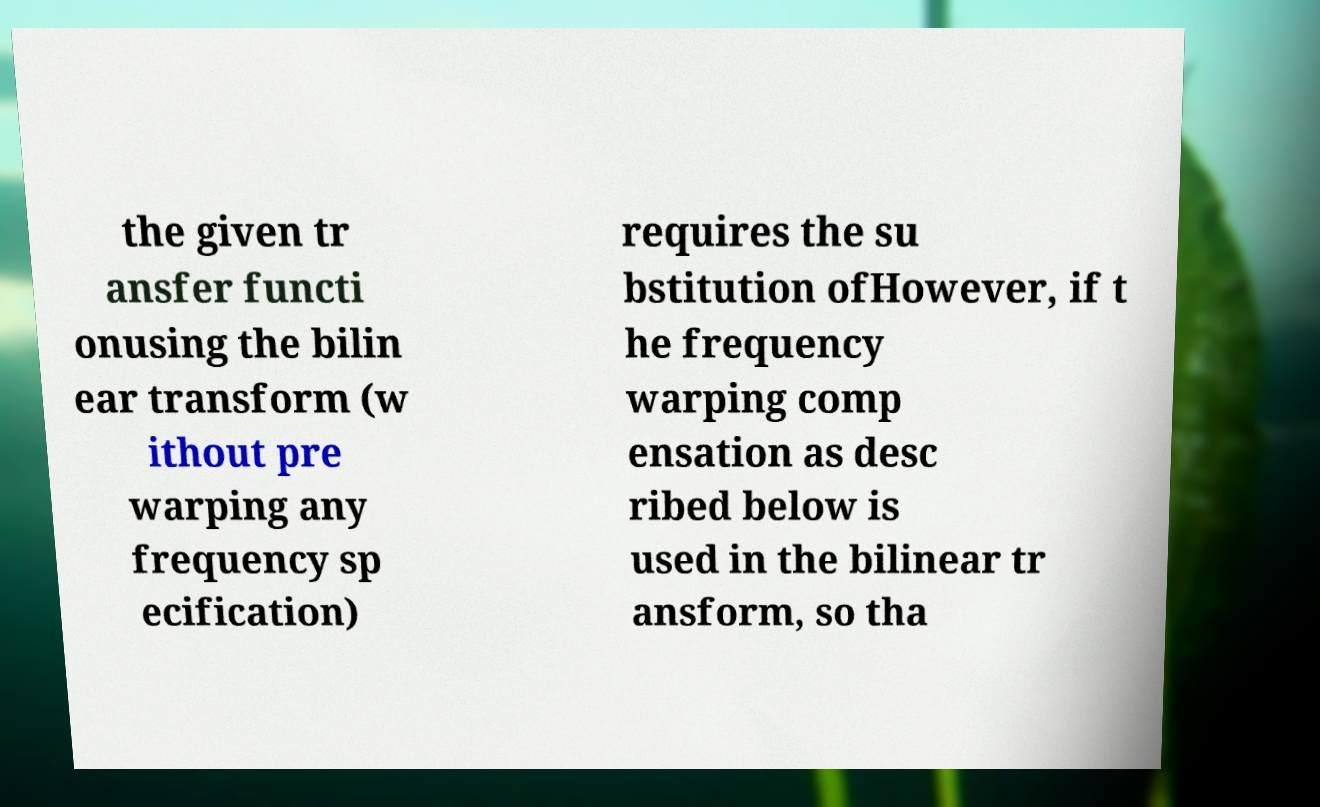Please read and relay the text visible in this image. What does it say? the given tr ansfer functi onusing the bilin ear transform (w ithout pre warping any frequency sp ecification) requires the su bstitution ofHowever, if t he frequency warping comp ensation as desc ribed below is used in the bilinear tr ansform, so tha 